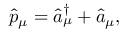<formula> <loc_0><loc_0><loc_500><loc_500>\hat { p } _ { \mu } = \hat { a } _ { \mu } ^ { \dagger } + \hat { a } _ { \mu } ,</formula> 